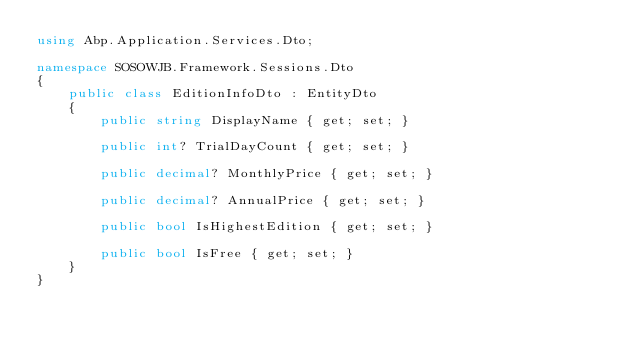Convert code to text. <code><loc_0><loc_0><loc_500><loc_500><_C#_>using Abp.Application.Services.Dto;

namespace SOSOWJB.Framework.Sessions.Dto
{
    public class EditionInfoDto : EntityDto
    {
        public string DisplayName { get; set; }

        public int? TrialDayCount { get; set; }

        public decimal? MonthlyPrice { get; set; }

        public decimal? AnnualPrice { get; set; }

        public bool IsHighestEdition { get; set; }

        public bool IsFree { get; set; }
    }
}</code> 